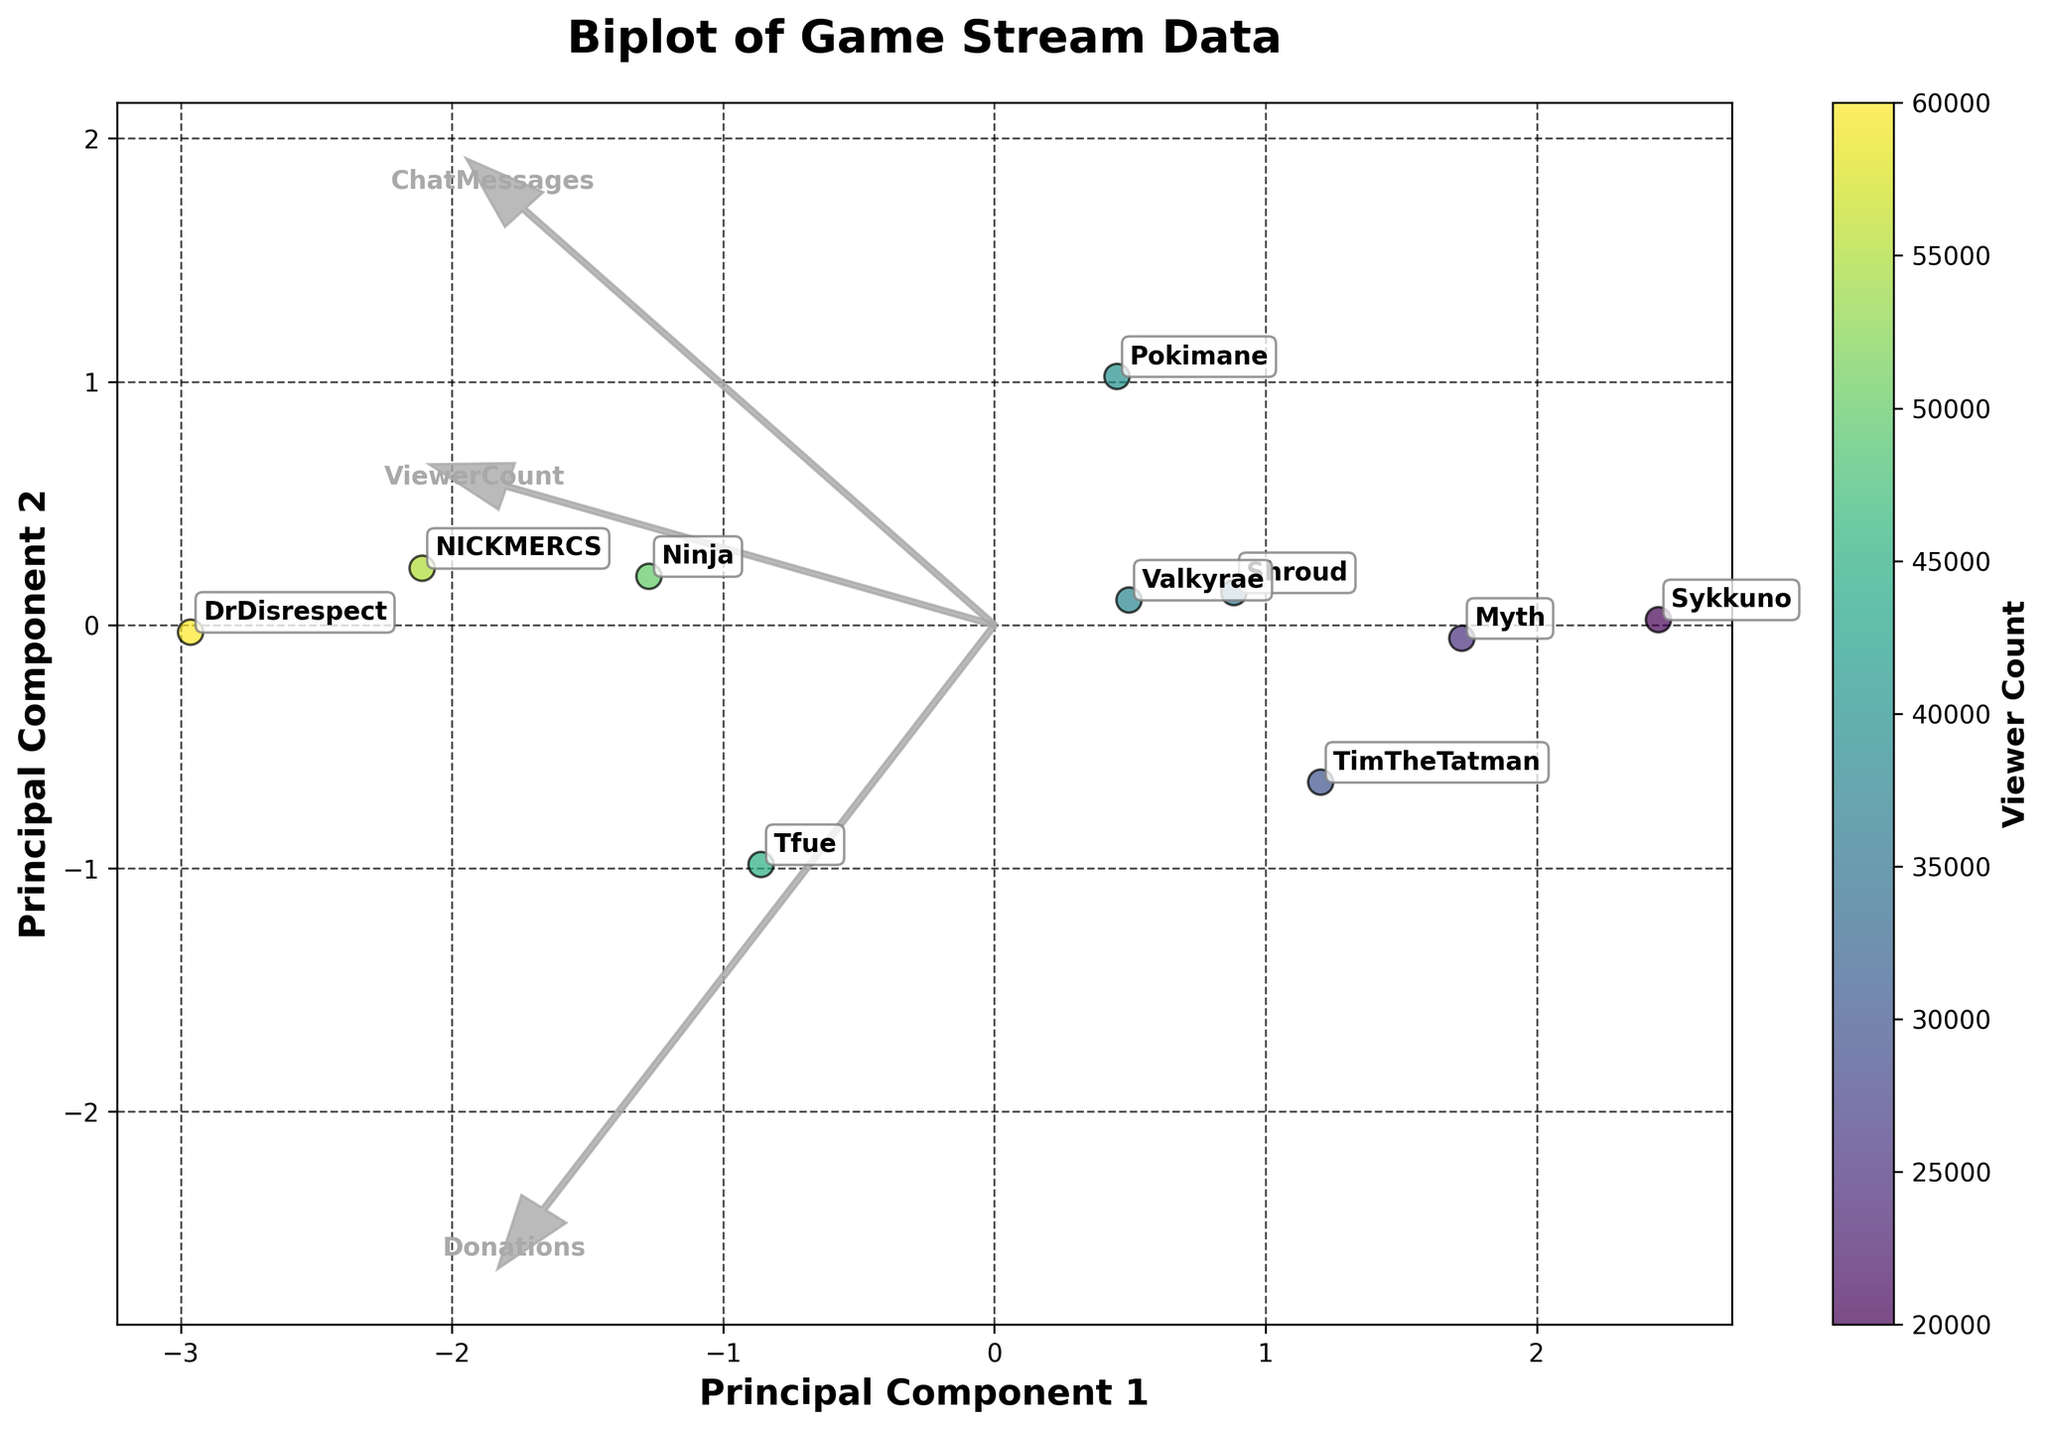What is the title of the biplot? The title of the biplot is displayed at the top of the figure.
Answer: Biplot of Game Stream Data How many streamers are represented in the biplot? The biplot has annotated points for each streamer, and count the number of annotations.
Answer: 10 Which game moment corresponds to the highest viewer count? Look for the annotation with the highest viewer count in the biplot. The color bar indicates the viewer count.
Answer: Victory Royale (DrDisrespect) Which two features have the longest vectors? In a biplot, the vectors represent the features. The length of the vectors indicates how much each feature contributes to the principal components.
Answer: ChatMessages and ViewerCount Which streamers have a close value for Principal Component 1? Look at the horizontal positions of the points, and find the ones that are close to each other on the x-axis (Principal Component 1).
Answer: Tfue and Ninja Which streamer is located furthest along Principal Component 2 (up or down)? Identify the streamer with the highest or lowest position on the y-axis (Principal Component 2).
Answer: Sykkuno How does the donation pattern correlate with viewer count? Observe the vectors for "Donations" and "ViewerCount" in the biplot. If they point in the same direction, there is a positive correlation; if they point in opposite directions, the correlation is negative.
Answer: Positive correlation Which streamer seems to have the highest chat messages but not the highest donations? Identify the streamer located nearest to the direction of the "ChatMessages" vector but not in the direction of the "Donations" vector.
Answer: Ninja Are chat messages and donations positively correlated based on the feature vectors? In the biplot, check the direction of the vectors for "ChatMessages" and "Donations". If they point in similar directions, they are positively correlated.
Answer: Yes Who has a significantly different Principal Component 2 value compared to Myth? Check the y-axis (Principal Component 2) and find a point that is situated significantly higher or lower compared to Myth's annotation.
Answer: Sykkuno 